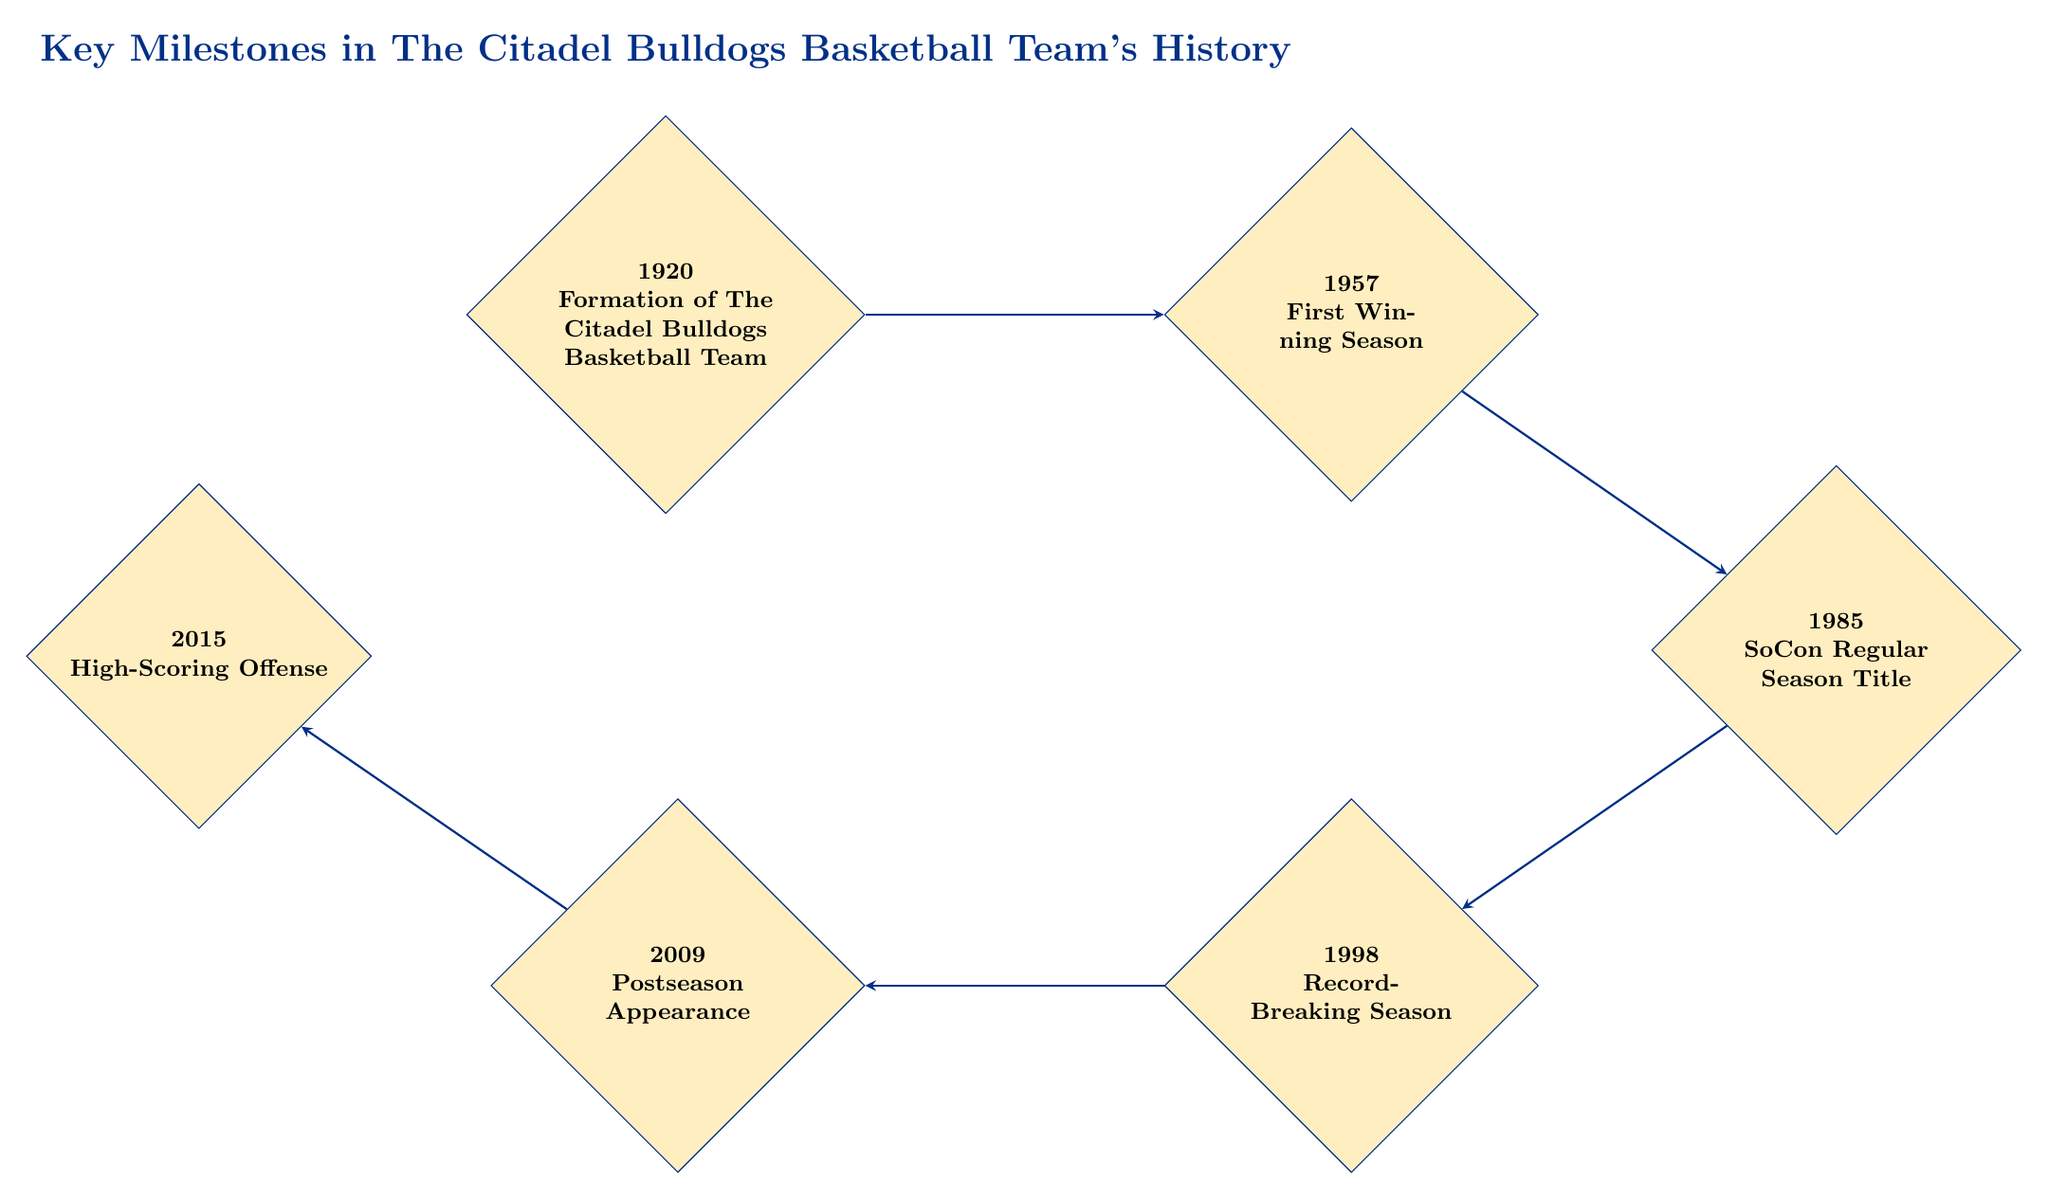What year was The Citadel Bulldogs Basketball Team formed? The diagram shows that the first milestone is from the year 1920, which states the formation of the team.
Answer: 1920 What significant achievement occurred in 1957? In 1957, the milestone describes that The Citadel Bulldogs achieved their first winning season.
Answer: First Winning Season How many milestones are listed in the diagram? The diagram lists a total of six milestones related to The Citadel Bulldogs history.
Answer: 6 What was the team's record in their first winning season? The details provided for the 1957 milestone specify that the record was 15-8 in their first winning season.
Answer: 15-8 Which milestone follows the SoCon Regular Season Title? The flow from the 1985 milestone shows an arrow leading down to the 1998 milestone, which represents the Record-Breaking Season.
Answer: Record-Breaking Season Between which years did The Citadel Bulldogs experience a record-breaking season? The diagram connects the milestones from 1985 (SoCon Regular Season Title) directly to 1998 (Record-Breaking Season), indicating that this period is between these two years.
Answer: 1985 and 1998 What milestone is associated with Coach Pat Dennis? The 1998 milestone specifies that the record-breaking season was under Coach Pat Dennis, which marks a notable achievement.
Answer: Record-Breaking Season What type of strategy did the Bulldogs adopt in 2015? The 2015 milestone indicates that under Coach Duggar Baucom, the team adopted a high-scoring offensive strategy, leading to several record-breaking scoring games.
Answer: High-Scoring Offense Which milestone represents the Bulldogs' first postseason appearance? The diagram indicates that the 2009 milestone details the team's first appearance in the CollegeInsider.com Postseason Tournament (CIT).
Answer: Postseason Appearance 